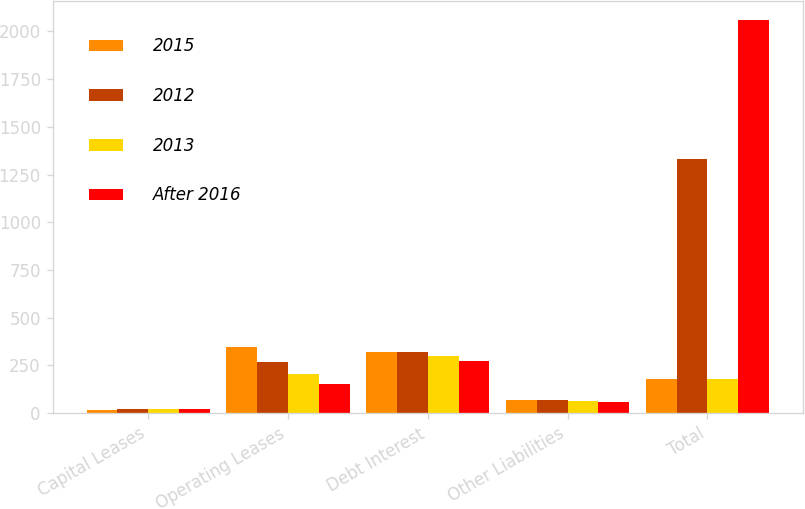<chart> <loc_0><loc_0><loc_500><loc_500><stacked_bar_chart><ecel><fcel>Capital Leases<fcel>Operating Leases<fcel>Debt Interest<fcel>Other Liabilities<fcel>Total<nl><fcel>2015<fcel>18<fcel>348<fcel>322<fcel>69<fcel>177.5<nl><fcel>2012<fcel>19<fcel>268<fcel>321<fcel>67<fcel>1334<nl><fcel>2013<fcel>19<fcel>205<fcel>300<fcel>64<fcel>177.5<nl><fcel>After 2016<fcel>20<fcel>150<fcel>274<fcel>58<fcel>2059<nl></chart> 